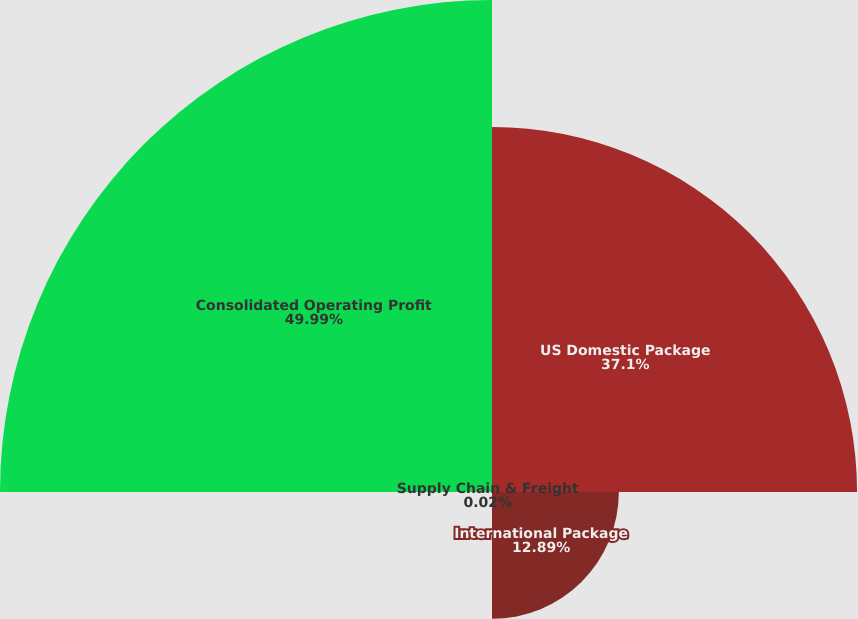Convert chart. <chart><loc_0><loc_0><loc_500><loc_500><pie_chart><fcel>US Domestic Package<fcel>International Package<fcel>Supply Chain & Freight<fcel>Consolidated Operating Profit<nl><fcel>37.1%<fcel>12.89%<fcel>0.02%<fcel>50.0%<nl></chart> 